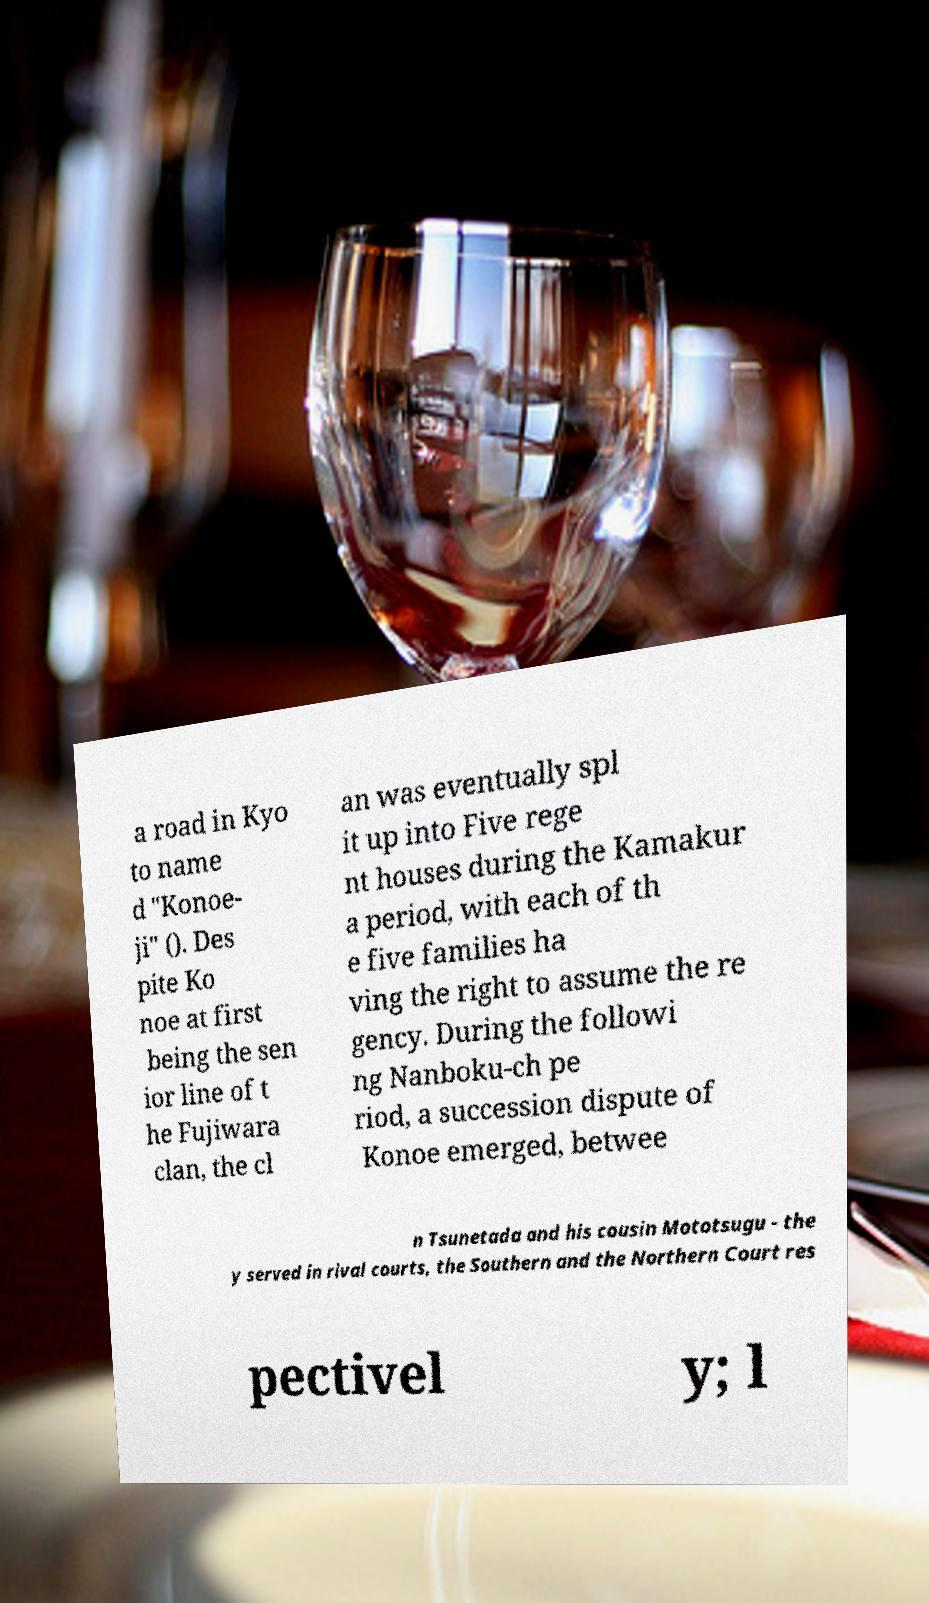Can you accurately transcribe the text from the provided image for me? a road in Kyo to name d "Konoe- ji" (). Des pite Ko noe at first being the sen ior line of t he Fujiwara clan, the cl an was eventually spl it up into Five rege nt houses during the Kamakur a period, with each of th e five families ha ving the right to assume the re gency. During the followi ng Nanboku-ch pe riod, a succession dispute of Konoe emerged, betwee n Tsunetada and his cousin Mototsugu - the y served in rival courts, the Southern and the Northern Court res pectivel y; l 